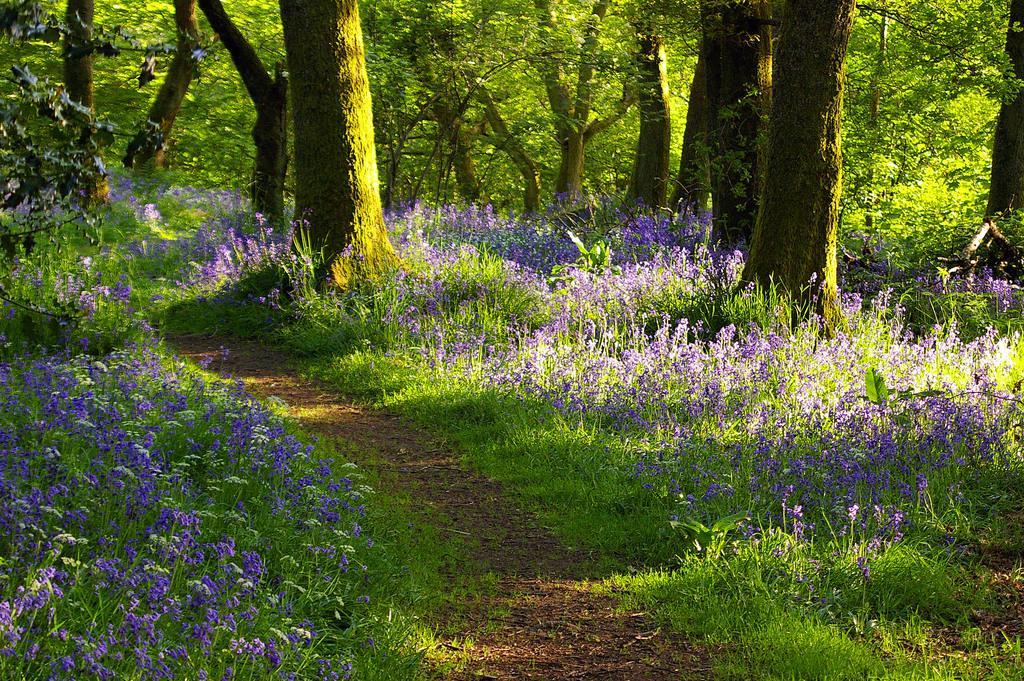Please provide a concise description of this image. In this image in the background there are some trees, and at the bottom there are some plants flowers and a walkway. 